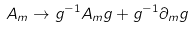Convert formula to latex. <formula><loc_0><loc_0><loc_500><loc_500>A _ { m } \rightarrow g ^ { - 1 } A _ { m } g + g ^ { - 1 } \partial _ { m } g</formula> 